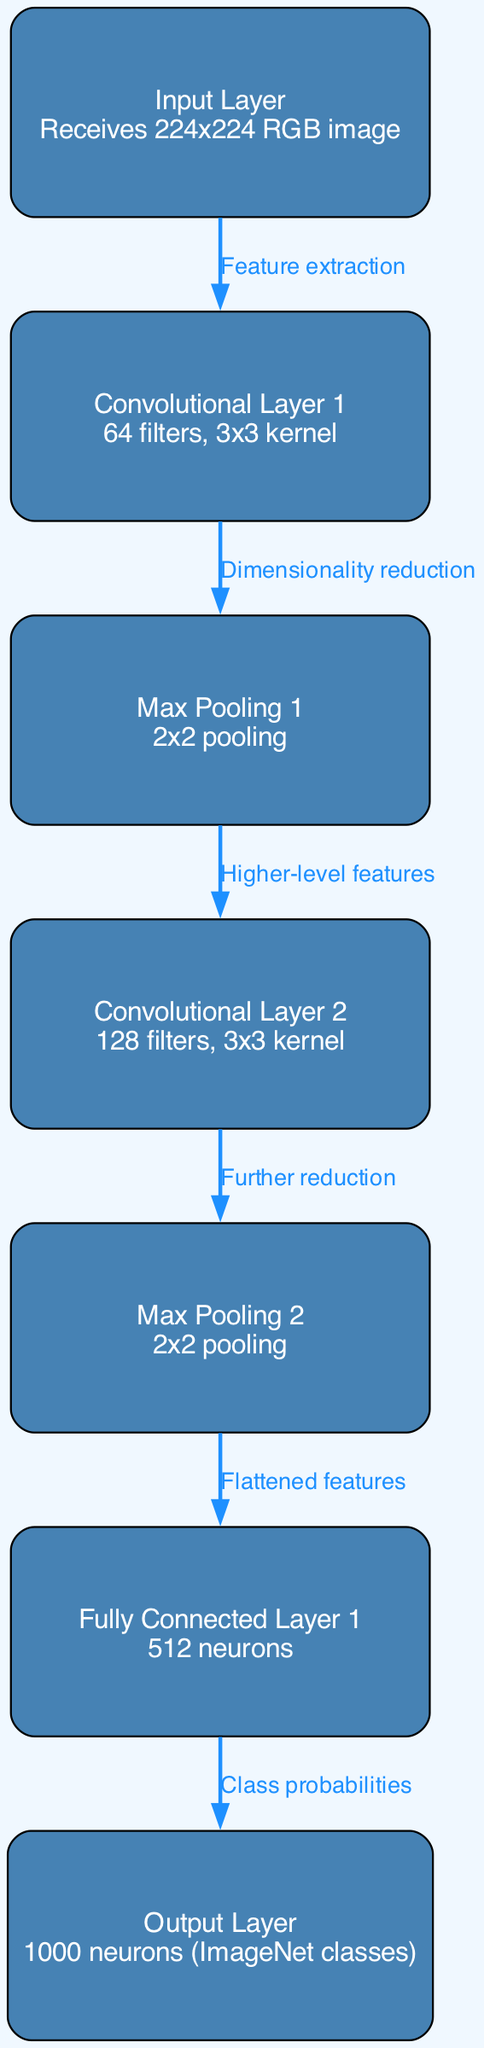What is the size of the input layer images? The input layer receives images of size 224x224. This information is specifically mentioned in the description of the input layer node.
Answer: 224x224 How many filters are used in Convolutional Layer 1? The description next to Convolutional Layer 1 states that it uses 64 filters. This is directly stated in the node’s description.
Answer: 64 What type of pooling is used in Max Pooling 1? Max Pooling 1 uses 2x2 pooling, which is part of the description found in the Max Pooling 1 node.
Answer: 2x2 How many neurons are in the output layer? The output layer consists of 1000 neurons, as indicated in the description of the output layer node. This is where the model outputs the probabilities for the ImageNet classes.
Answer: 1000 What is the purpose of the edge connecting Input Layer to Convolutional Layer 1? The edge from the Input Layer to Convolutional Layer 1 is labeled "Feature extraction," indicating that this transition is where feature extraction occurs in the model.
Answer: Feature extraction What is the relationship between Pooling Layer 2 and Fully Connected Layer 1? The edge from Pooling Layer 2 to Fully Connected Layer 1 is labeled "Flattened features," indicating that this layer receives the flattened features from the previous pooling operation.
Answer: Flattened features How many layers are there in total? There are seven layers in total if you count the input layer, the two convolutional layers, the two pooling layers, the fully connected layer, and the output layer. This includes all nodes within the diagram.
Answer: 7 What kind of features does Convolutional Layer 2 extract? The relationship leading to Convolutional Layer 2 from Pooling Layer 1 is described as "Higher-level features," which means this layer extracts more abstract characteristics compared to the previous layers.
Answer: Higher-level features What does Fully Connected Layer 1 output represent? Fully Connected Layer 1 outputs class probabilities, as indicated in the edge leading to the output layer, specifically labeled as "Class probabilities."
Answer: Class probabilities 